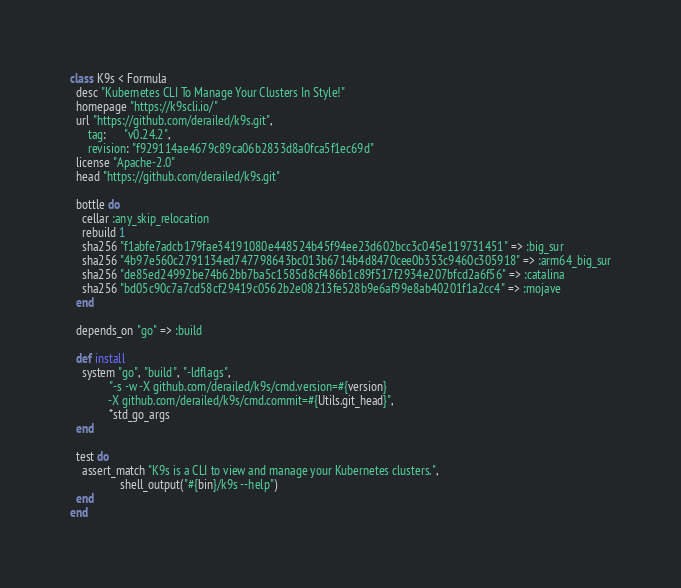Convert code to text. <code><loc_0><loc_0><loc_500><loc_500><_Ruby_>class K9s < Formula
  desc "Kubernetes CLI To Manage Your Clusters In Style!"
  homepage "https://k9scli.io/"
  url "https://github.com/derailed/k9s.git",
      tag:      "v0.24.2",
      revision: "f929114ae4679c89ca06b2833d8a0fca5f1ec69d"
  license "Apache-2.0"
  head "https://github.com/derailed/k9s.git"

  bottle do
    cellar :any_skip_relocation
    rebuild 1
    sha256 "f1abfe7adcb179fae34191080e448524b45f94ee23d602bcc3c045e119731451" => :big_sur
    sha256 "4b97e560c2791134ed747798643bc013b6714b4d8470cee0b353c9460c305918" => :arm64_big_sur
    sha256 "de85ed24992be74b62bb7ba5c1585d8cf486b1c89f517f2934e207bfcd2a6f56" => :catalina
    sha256 "bd05c90c7a7cd58cf29419c0562b2e08213fe528b9e6af99e8ab40201f1a2cc4" => :mojave
  end

  depends_on "go" => :build

  def install
    system "go", "build", "-ldflags",
             "-s -w -X github.com/derailed/k9s/cmd.version=#{version}
             -X github.com/derailed/k9s/cmd.commit=#{Utils.git_head}",
             *std_go_args
  end

  test do
    assert_match "K9s is a CLI to view and manage your Kubernetes clusters.",
                 shell_output("#{bin}/k9s --help")
  end
end
</code> 